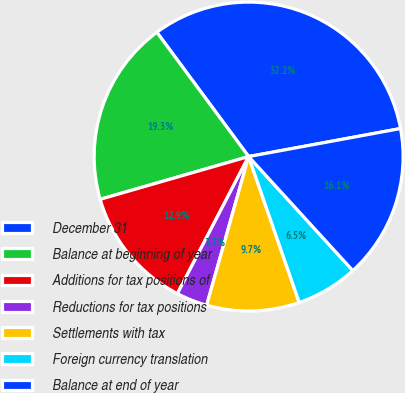<chart> <loc_0><loc_0><loc_500><loc_500><pie_chart><fcel>December 31<fcel>Balance at beginning of year<fcel>Additions for tax positions of<fcel>Reductions for tax positions<fcel>Settlements with tax<fcel>Foreign currency translation<fcel>Balance at end of year<nl><fcel>32.22%<fcel>19.34%<fcel>12.91%<fcel>3.25%<fcel>9.69%<fcel>6.47%<fcel>16.12%<nl></chart> 